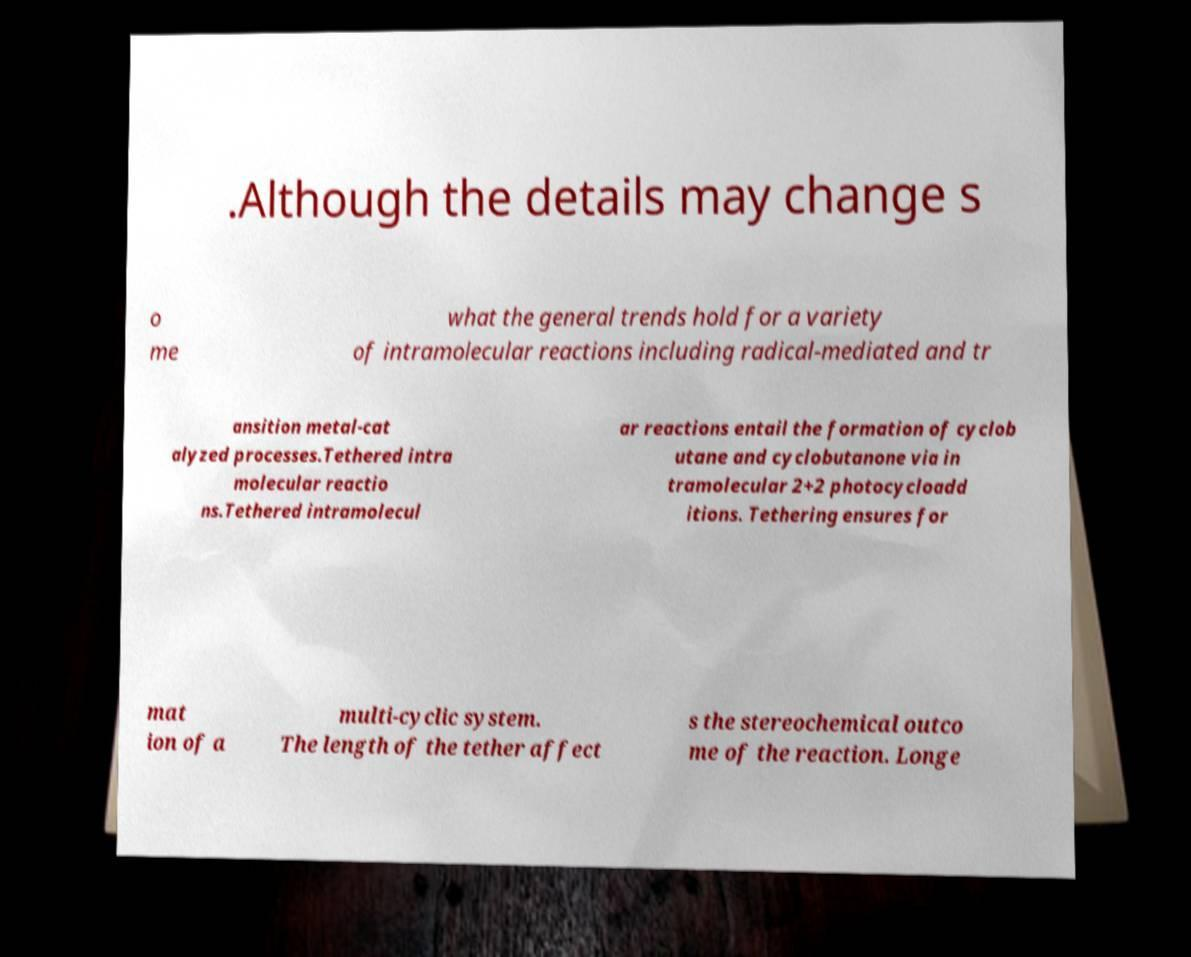I need the written content from this picture converted into text. Can you do that? .Although the details may change s o me what the general trends hold for a variety of intramolecular reactions including radical-mediated and tr ansition metal-cat alyzed processes.Tethered intra molecular reactio ns.Tethered intramolecul ar reactions entail the formation of cyclob utane and cyclobutanone via in tramolecular 2+2 photocycloadd itions. Tethering ensures for mat ion of a multi-cyclic system. The length of the tether affect s the stereochemical outco me of the reaction. Longe 